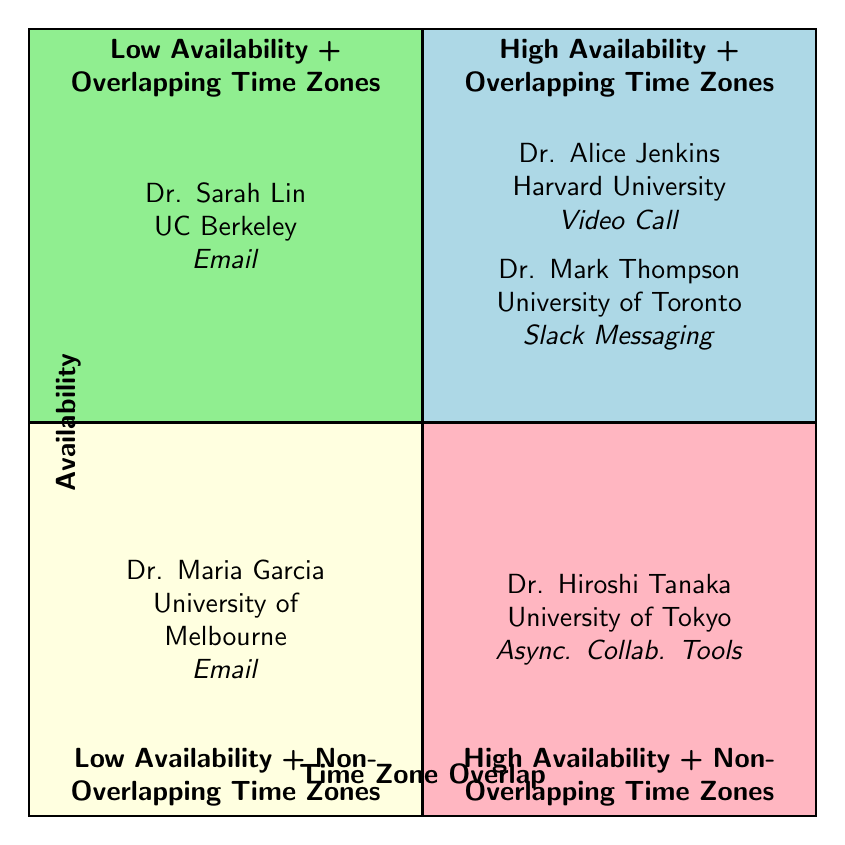What is the preferred communication method for Dr. Alice Jenkins? The diagram indicates that Dr. Alice Jenkins prefers to communicate via video call. This information can be found in the contents of the first quadrant.
Answer: Video Call How many collaborators are listed in total? By reviewing all four quadrants, we find a total of five collaborators listed across the chart. This includes Dr. Alice Jenkins, Dr. Mark Thompson, Dr. Sarah Lin, Dr. Hiroshi Tanaka, and Dr. Maria Garcia.
Answer: 5 Which quadrant contains Dr. Sarah Lin? Dr. Sarah Lin is found in the second quadrant, which is designated for low availability and overlapping time zones. This can be verified by locating her name in the contents of that quadrant.
Answer: Low Availability + Overlapping Time Zones What institutions are represented in the high availability overlapping time zones quadrant? The institutions represented in the high availability and overlapping time zones quadrant are Harvard University and University of Toronto, as Dr. Alice Jenkins and Dr. Mark Thompson are the collaborators in that section.
Answer: Harvard University, University of Toronto Which collaborator is associated with asynchronous collaboration tools? In the quadrant for high availability and non-overlapping time zones, Dr. Hiroshi Tanaka is noted as the collaborator who prefers asynchronous collaboration tools. This is derived from the contents of that quadrant.
Answer: Dr. Hiroshi Tanaka How many collaborators have email as their preferred method of communication? There are two collaborators, Dr. Sarah Lin and Dr. Maria Garcia, who both prefer email communication. This can be deduced by examining the contents of the relevant quadrants.
Answer: 2 